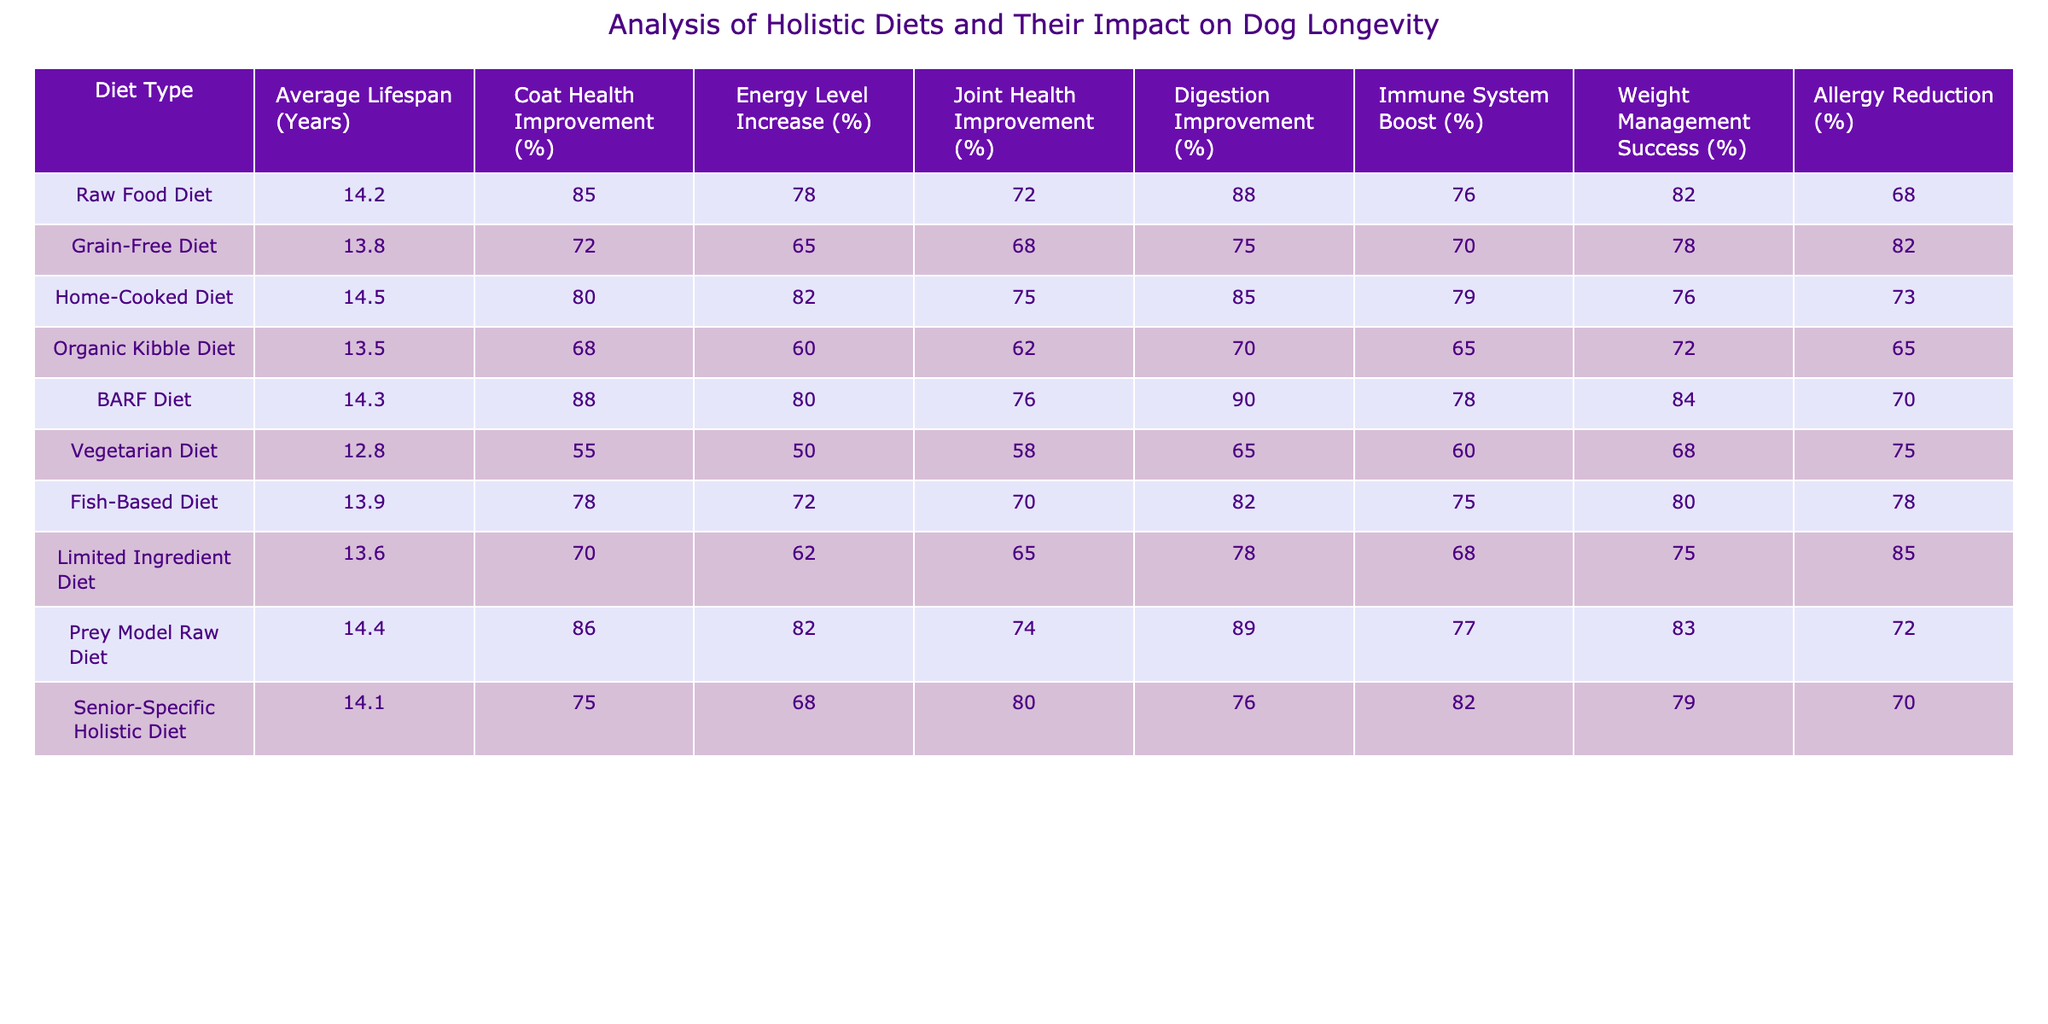What is the average lifespan of dogs on a Raw Food Diet? According to the table, the average lifespan for dogs on a Raw Food Diet is listed as 14.2 years.
Answer: 14.2 years Which diet type shows the most improvement in coat health? The BARF Diet shows the highest improvement in coat health at 88%.
Answer: BARF Diet What is the difference in average lifespan between the Vegetarian Diet and the Home-Cooked Diet? The average lifespan for the Vegetarian Diet is 12.8 years, and for the Home-Cooked Diet, it is 14.5 years. The difference is 14.5 - 12.8 = 1.7 years.
Answer: 1.7 years Is it true that the Grain-Free Diet provides an energy level increase greater than 70%? The Grain-Free Diet shows an energy level increase of 65%, which is less than 70%. Therefore, it is false.
Answer: No What is the average coat health improvement for all diet types listed? To find the average, we add all the coat health improvements: (85 + 72 + 80 + 68 + 88 + 55 + 78 + 70 + 86 + 75) = 786. There are 10 diet types, so the average is 786/10 = 78.6%.
Answer: 78.6% Which diet has the lowest average lifespan? The Vegetarian Diet has the lowest average lifespan at 12.8 years.
Answer: 12.8 years How does the Joint Health Improvement of a Fish-Based Diet compare to that of the Prey Model Raw Diet? The Fish-Based Diet has a Joint Health Improvement of 70%, while the Prey Model Raw Diet has 74%. Since 74% > 70%, the Prey Model Raw Diet has a higher improvement.
Answer: Prey Model Raw Diet has higher improvement What percentage of Allergy Reduction does the Limited Ingredient Diet provide? The table indicates that the Limited Ingredient Diet provides an Allergy Reduction of 85%.
Answer: 85% Calculate the improvement percentage in Digestion for the Organic Kibble Diet compared to the BARF Diet. The Organic Kibble Diet has a Digestion Improvement of 70%, while the BARF Diet has 90%. The difference is 90 - 70 = 20%. Therefore, the Organic Kibble Diet has 20% less improvement compared to the BARF Diet.
Answer: 20% less improvement Which two diets have the closest average lifespan? The Fish-Based Diet is 13.9 years, and the Limited Ingredient Diet is 13.6 years. The difference is 0.3 years, making them the closest.
Answer: Fish-Based Diet and Limited Ingredient Diet 